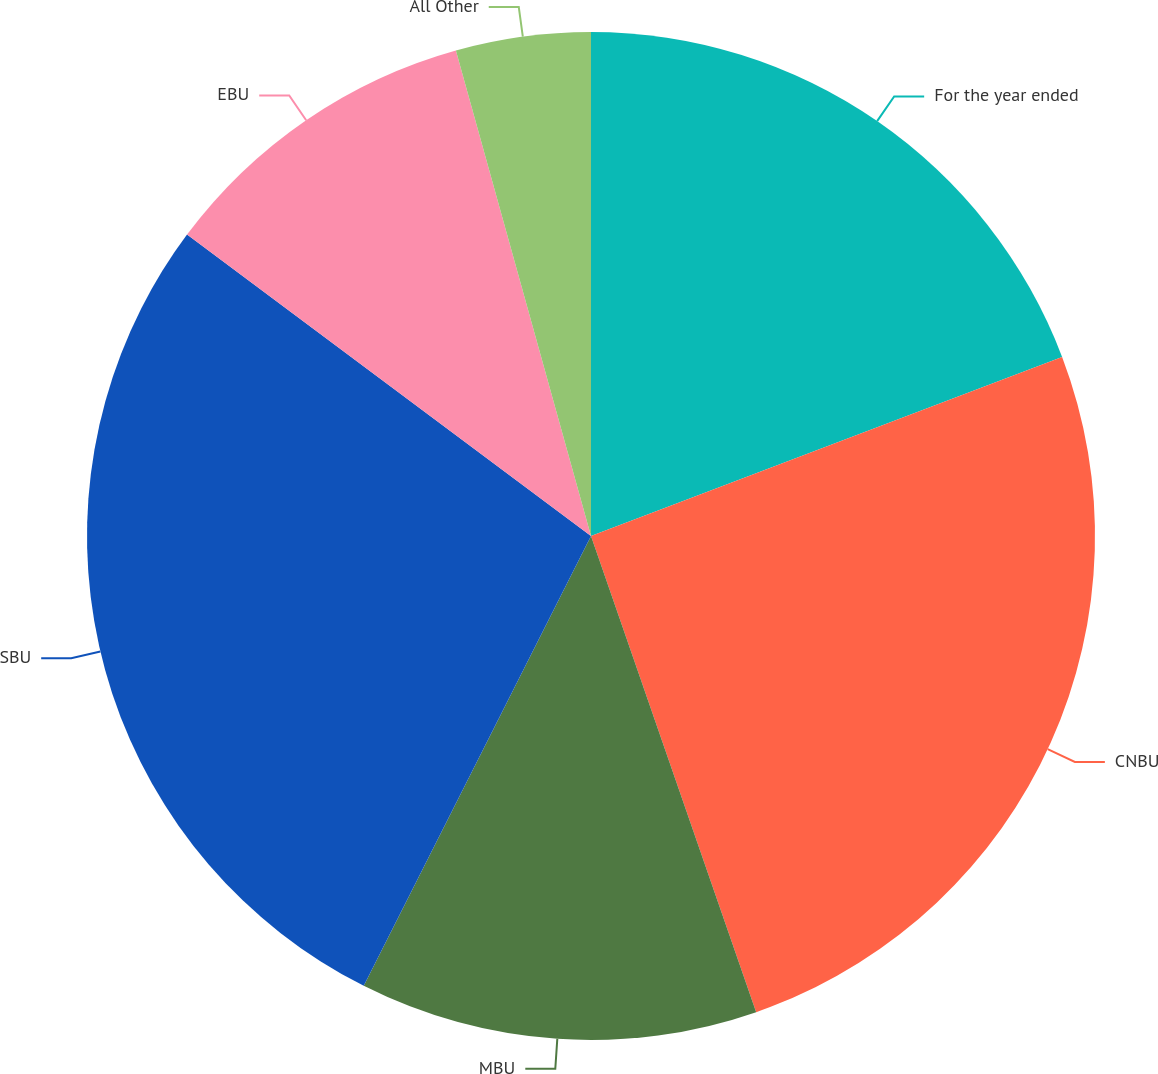Convert chart. <chart><loc_0><loc_0><loc_500><loc_500><pie_chart><fcel>For the year ended<fcel>CNBU<fcel>MBU<fcel>SBU<fcel>EBU<fcel>All Other<nl><fcel>19.22%<fcel>25.47%<fcel>12.76%<fcel>27.76%<fcel>10.48%<fcel>4.32%<nl></chart> 